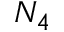Convert formula to latex. <formula><loc_0><loc_0><loc_500><loc_500>N _ { 4 }</formula> 